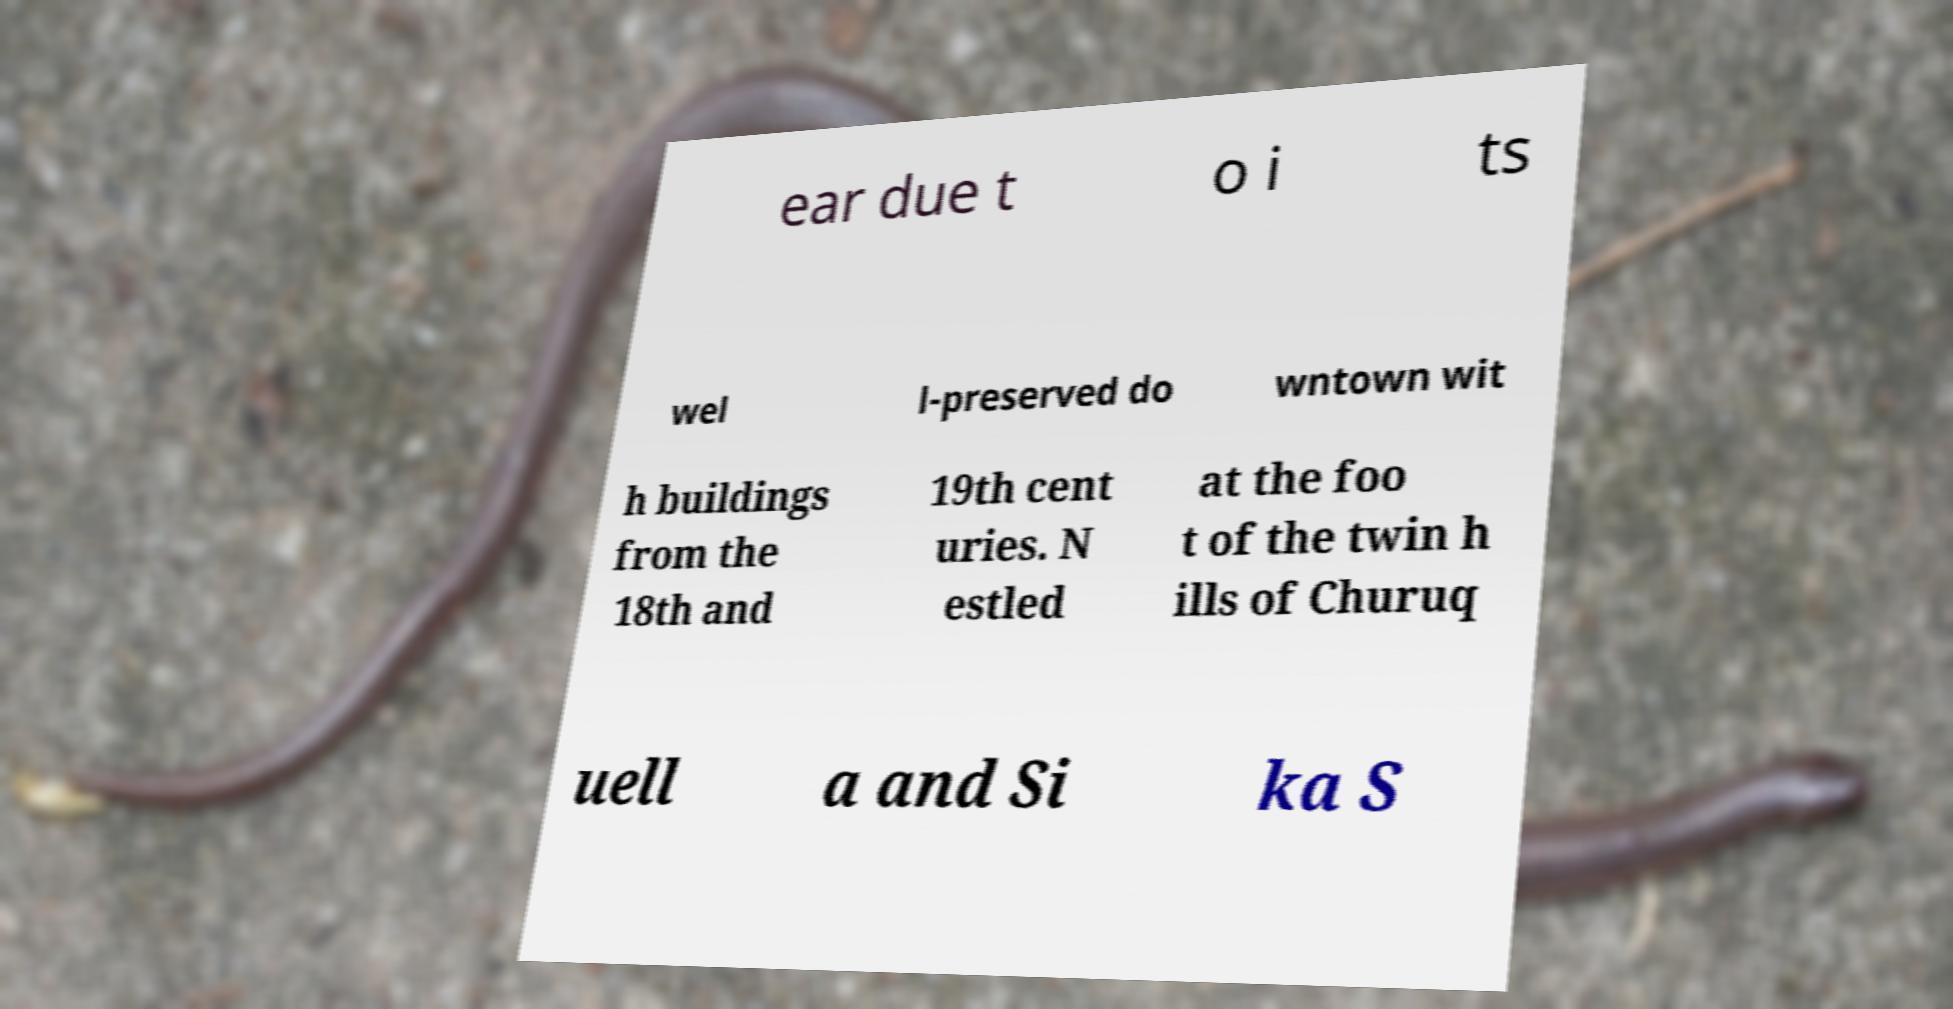Could you extract and type out the text from this image? ear due t o i ts wel l-preserved do wntown wit h buildings from the 18th and 19th cent uries. N estled at the foo t of the twin h ills of Churuq uell a and Si ka S 